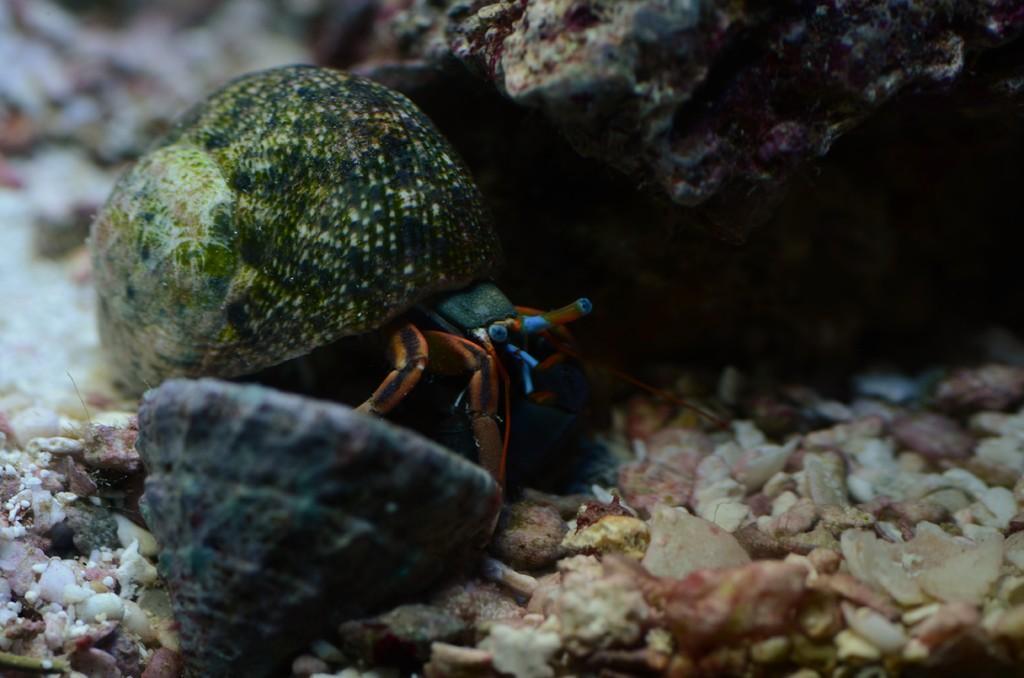Could you give a brief overview of what you see in this image? In this image, we can see crab, shells and stones. 